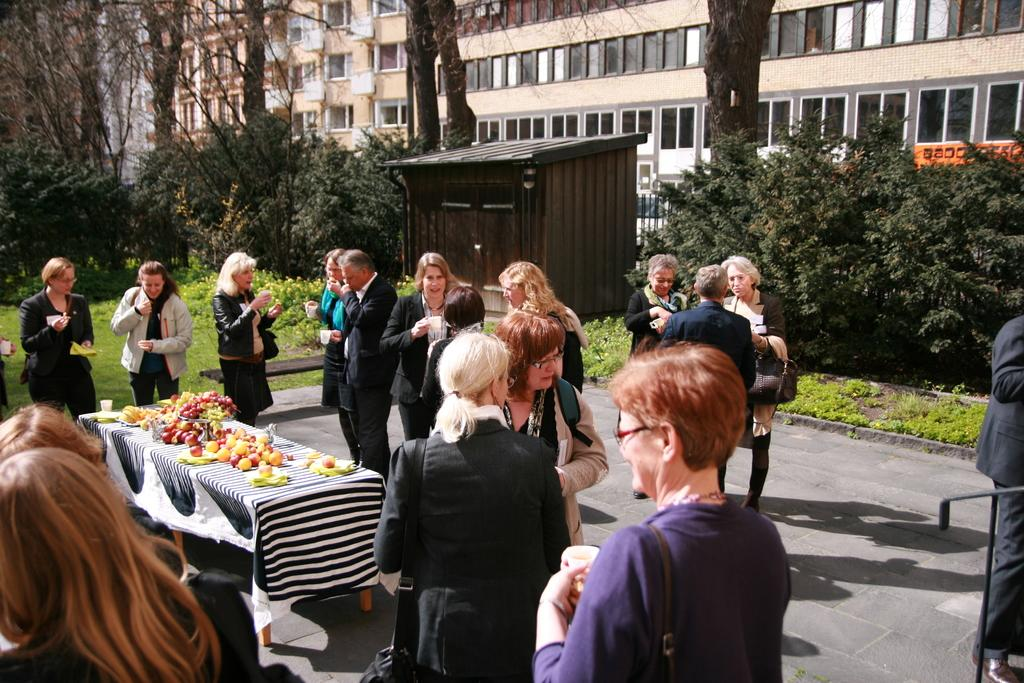What types of people are present in the image? There are men and women standing in the image. What structures can be seen in the background? There are buildings with windows in the image. What type of vegetation is visible in the image? There are trees in the image. What edible items are on the table in the image? There are fruits on a table in the image. What type of vest is being worn by the person in the cemetery in the image? There is no cemetery or person wearing a vest present in the image. 